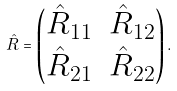<formula> <loc_0><loc_0><loc_500><loc_500>\hat { R } = \begin{pmatrix} \hat { R } _ { 1 1 } & \hat { R } _ { 1 2 } \\ \hat { R } _ { 2 1 } & \hat { R } _ { 2 2 } \end{pmatrix} .</formula> 